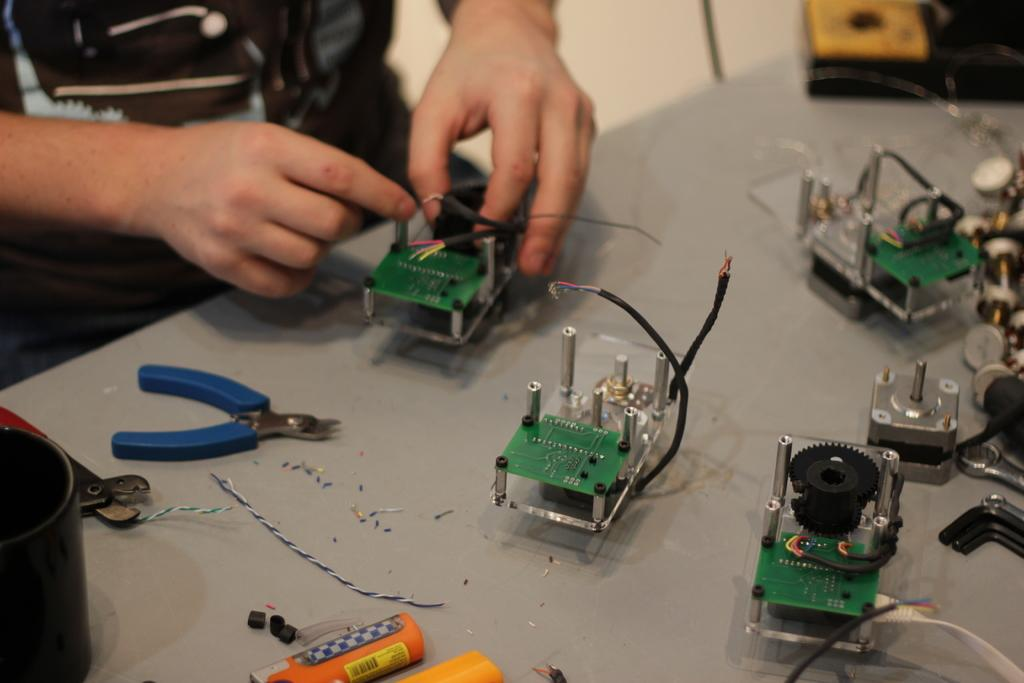What type of furniture is in the image? There is a table in the image. What tools are on the table? Cutters are present on the table. What else can be seen on the table? Wires and electric equipment are visible on the table. What is happening in the background of the image? There is a person holding an electrical equipment in the background. What type of destruction can be seen in the image? There is no destruction present in the image. 